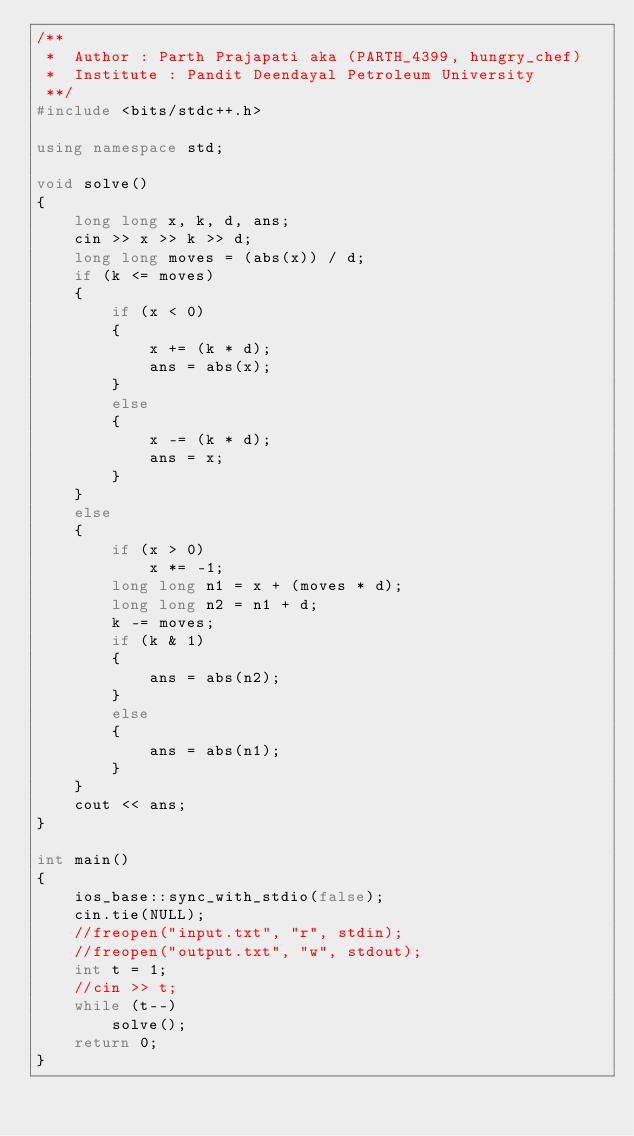Convert code to text. <code><loc_0><loc_0><loc_500><loc_500><_C++_>/**
 *  Author : Parth Prajapati aka (PARTH_4399, hungry_chef)
 *  Institute : Pandit Deendayal Petroleum University
 **/
#include <bits/stdc++.h>

using namespace std;

void solve()
{
    long long x, k, d, ans;
    cin >> x >> k >> d;
    long long moves = (abs(x)) / d;
    if (k <= moves)
    {
        if (x < 0)
        {
            x += (k * d);
            ans = abs(x);
        }
        else
        {
            x -= (k * d);
            ans = x;
        }
    }
    else
    {
        if (x > 0)
            x *= -1;
        long long n1 = x + (moves * d);
        long long n2 = n1 + d;
        k -= moves;
        if (k & 1)
        {
            ans = abs(n2);
        }
        else
        {
            ans = abs(n1);
        }
    }
    cout << ans;
}

int main()
{
    ios_base::sync_with_stdio(false);
    cin.tie(NULL);
    //freopen("input.txt", "r", stdin);
    //freopen("output.txt", "w", stdout);
    int t = 1;
    //cin >> t;
    while (t--)
        solve();
    return 0;
}</code> 